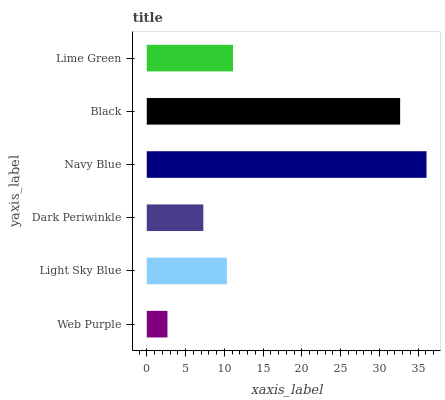Is Web Purple the minimum?
Answer yes or no. Yes. Is Navy Blue the maximum?
Answer yes or no. Yes. Is Light Sky Blue the minimum?
Answer yes or no. No. Is Light Sky Blue the maximum?
Answer yes or no. No. Is Light Sky Blue greater than Web Purple?
Answer yes or no. Yes. Is Web Purple less than Light Sky Blue?
Answer yes or no. Yes. Is Web Purple greater than Light Sky Blue?
Answer yes or no. No. Is Light Sky Blue less than Web Purple?
Answer yes or no. No. Is Lime Green the high median?
Answer yes or no. Yes. Is Light Sky Blue the low median?
Answer yes or no. Yes. Is Navy Blue the high median?
Answer yes or no. No. Is Black the low median?
Answer yes or no. No. 